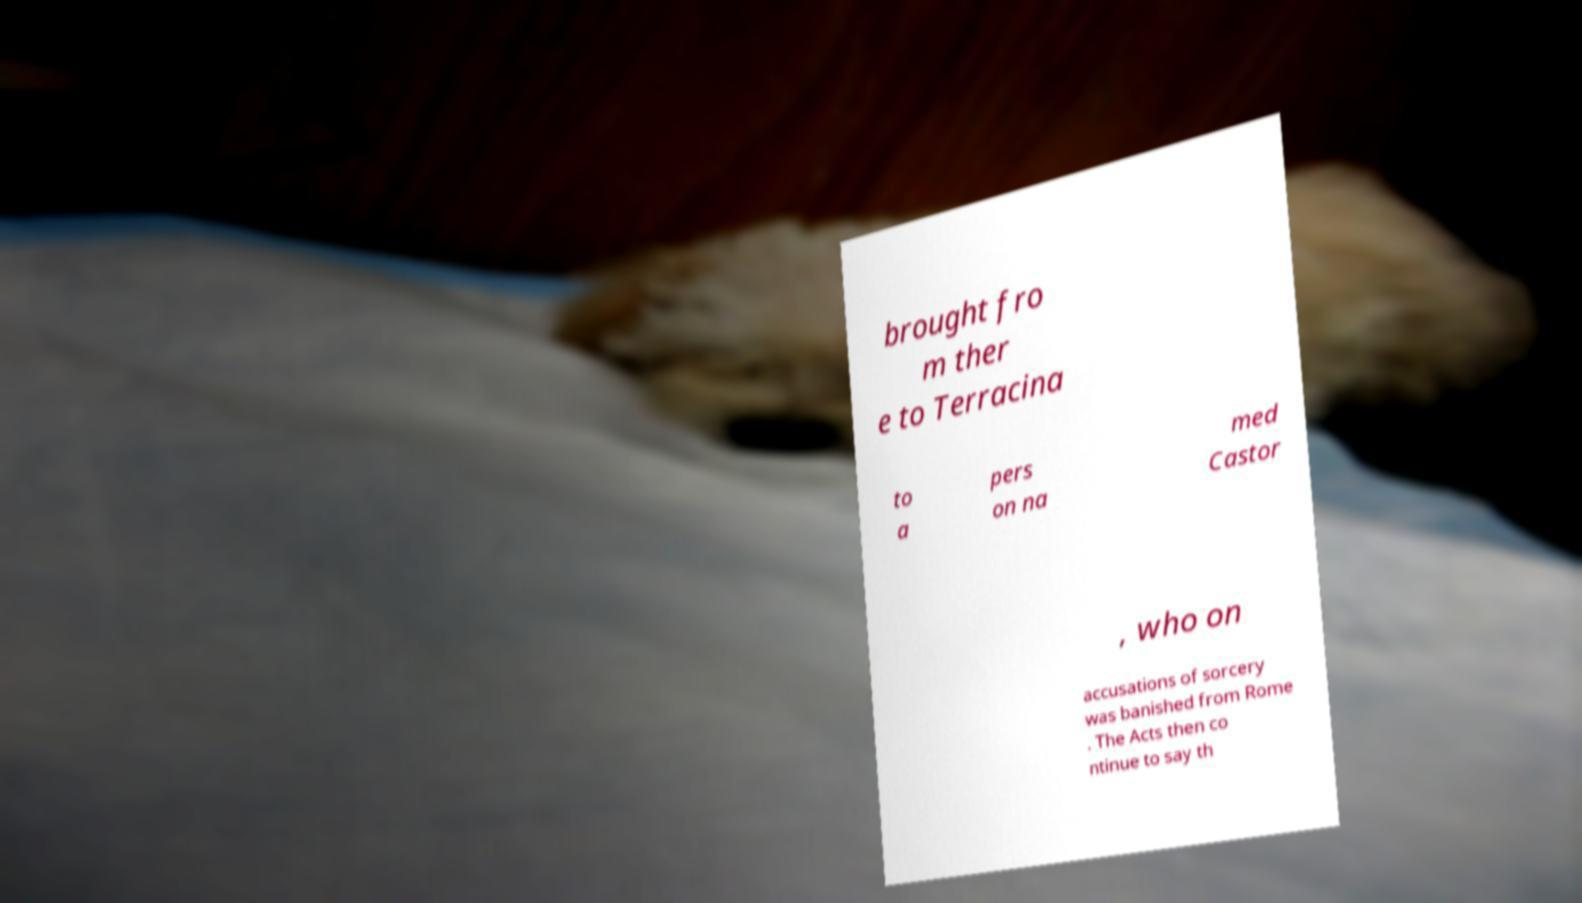What messages or text are displayed in this image? I need them in a readable, typed format. brought fro m ther e to Terracina to a pers on na med Castor , who on accusations of sorcery was banished from Rome . The Acts then co ntinue to say th 